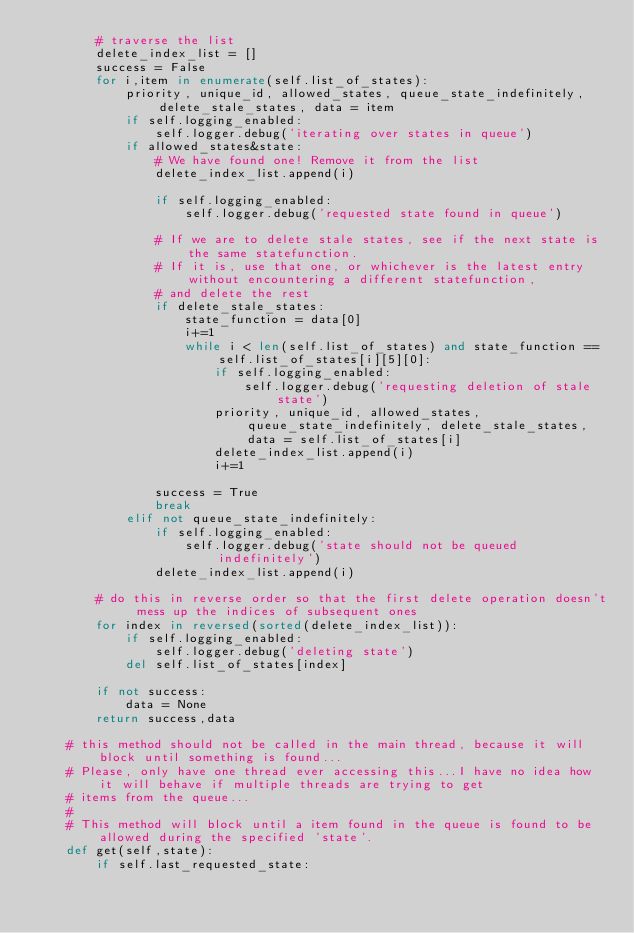Convert code to text. <code><loc_0><loc_0><loc_500><loc_500><_Python_>        # traverse the list
        delete_index_list = []
        success = False
        for i,item in enumerate(self.list_of_states):
            priority, unique_id, allowed_states, queue_state_indefinitely, delete_stale_states, data = item
            if self.logging_enabled:
                self.logger.debug('iterating over states in queue')
            if allowed_states&state:
                # We have found one! Remove it from the list
                delete_index_list.append(i)
                
                if self.logging_enabled:
                    self.logger.debug('requested state found in queue')
                
                # If we are to delete stale states, see if the next state is the same statefunction.
                # If it is, use that one, or whichever is the latest entry without encountering a different statefunction,
                # and delete the rest
                if delete_stale_states:
                    state_function = data[0]
                    i+=1
                    while i < len(self.list_of_states) and state_function == self.list_of_states[i][5][0]:
                        if self.logging_enabled:
                            self.logger.debug('requesting deletion of stale state')
                        priority, unique_id, allowed_states, queue_state_indefinitely, delete_stale_states, data = self.list_of_states[i]
                        delete_index_list.append(i)
                        i+=1
                
                success = True
                break
            elif not queue_state_indefinitely:
                if self.logging_enabled:
                    self.logger.debug('state should not be queued indefinitely')
                delete_index_list.append(i)
        
        # do this in reverse order so that the first delete operation doesn't mess up the indices of subsequent ones
        for index in reversed(sorted(delete_index_list)):
            if self.logging_enabled:
                self.logger.debug('deleting state')
            del self.list_of_states[index]
            
        if not success:
            data = None
        return success,data    
        
    # this method should not be called in the main thread, because it will block until something is found...
    # Please, only have one thread ever accessing this...I have no idea how it will behave if multiple threads are trying to get
    # items from the queue...
    #
    # This method will block until a item found in the queue is found to be allowed during the specified 'state'.
    def get(self,state):
        if self.last_requested_state:</code> 